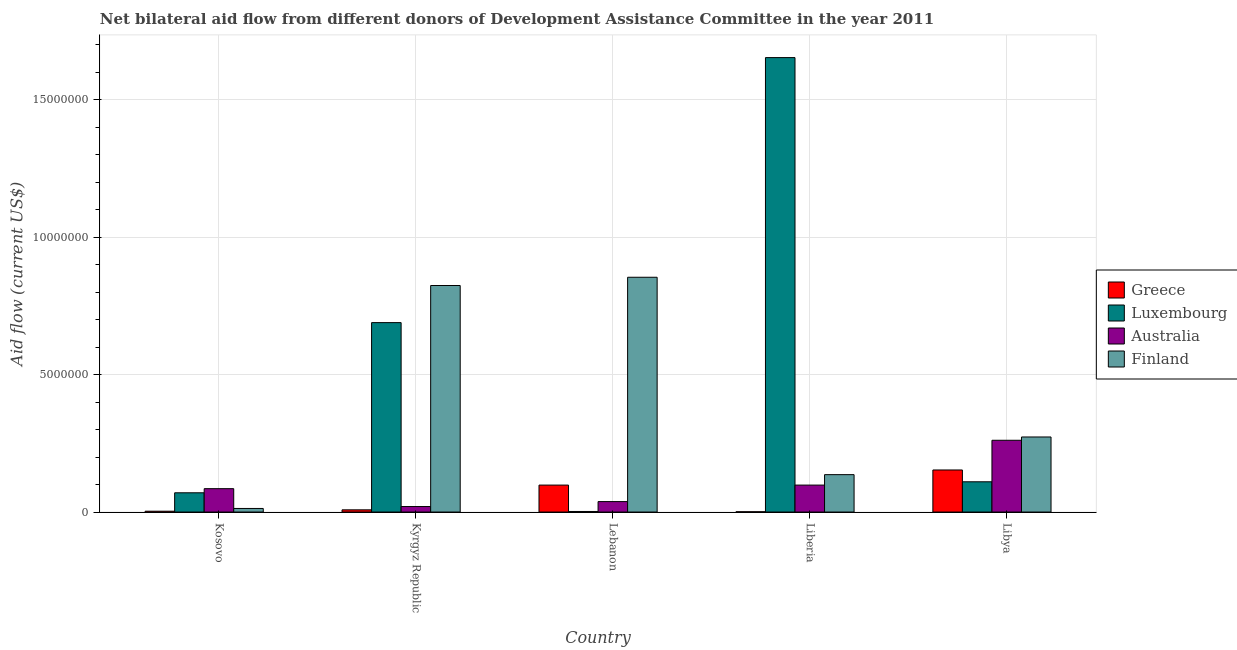How many different coloured bars are there?
Provide a short and direct response. 4. How many groups of bars are there?
Offer a very short reply. 5. Are the number of bars on each tick of the X-axis equal?
Make the answer very short. Yes. What is the label of the 2nd group of bars from the left?
Ensure brevity in your answer.  Kyrgyz Republic. In how many cases, is the number of bars for a given country not equal to the number of legend labels?
Keep it short and to the point. 0. What is the amount of aid given by finland in Libya?
Offer a very short reply. 2.73e+06. Across all countries, what is the maximum amount of aid given by finland?
Provide a succinct answer. 8.54e+06. Across all countries, what is the minimum amount of aid given by greece?
Provide a short and direct response. 10000. In which country was the amount of aid given by finland maximum?
Offer a very short reply. Lebanon. In which country was the amount of aid given by greece minimum?
Give a very brief answer. Liberia. What is the total amount of aid given by luxembourg in the graph?
Your response must be concise. 2.52e+07. What is the difference between the amount of aid given by finland in Kosovo and that in Libya?
Provide a succinct answer. -2.60e+06. What is the difference between the amount of aid given by australia in Liberia and the amount of aid given by luxembourg in Libya?
Your response must be concise. -1.20e+05. What is the average amount of aid given by luxembourg per country?
Give a very brief answer. 5.05e+06. What is the difference between the amount of aid given by australia and amount of aid given by greece in Kyrgyz Republic?
Give a very brief answer. 1.20e+05. What is the ratio of the amount of aid given by luxembourg in Lebanon to that in Libya?
Provide a short and direct response. 0.02. Is the amount of aid given by greece in Kosovo less than that in Libya?
Make the answer very short. Yes. What is the difference between the highest and the second highest amount of aid given by luxembourg?
Your answer should be very brief. 9.64e+06. What is the difference between the highest and the lowest amount of aid given by australia?
Make the answer very short. 2.41e+06. In how many countries, is the amount of aid given by greece greater than the average amount of aid given by greece taken over all countries?
Offer a very short reply. 2. Is the sum of the amount of aid given by luxembourg in Kosovo and Lebanon greater than the maximum amount of aid given by greece across all countries?
Offer a very short reply. No. Is it the case that in every country, the sum of the amount of aid given by australia and amount of aid given by greece is greater than the sum of amount of aid given by luxembourg and amount of aid given by finland?
Provide a succinct answer. No. What does the 3rd bar from the right in Kyrgyz Republic represents?
Your response must be concise. Luxembourg. How many bars are there?
Make the answer very short. 20. Are all the bars in the graph horizontal?
Your answer should be very brief. No. What is the difference between two consecutive major ticks on the Y-axis?
Provide a succinct answer. 5.00e+06. Does the graph contain any zero values?
Your response must be concise. No. How many legend labels are there?
Your answer should be very brief. 4. What is the title of the graph?
Ensure brevity in your answer.  Net bilateral aid flow from different donors of Development Assistance Committee in the year 2011. What is the label or title of the X-axis?
Offer a terse response. Country. What is the label or title of the Y-axis?
Ensure brevity in your answer.  Aid flow (current US$). What is the Aid flow (current US$) of Australia in Kosovo?
Your answer should be compact. 8.50e+05. What is the Aid flow (current US$) of Finland in Kosovo?
Provide a short and direct response. 1.30e+05. What is the Aid flow (current US$) of Luxembourg in Kyrgyz Republic?
Provide a short and direct response. 6.89e+06. What is the Aid flow (current US$) of Australia in Kyrgyz Republic?
Provide a short and direct response. 2.00e+05. What is the Aid flow (current US$) in Finland in Kyrgyz Republic?
Provide a short and direct response. 8.24e+06. What is the Aid flow (current US$) of Greece in Lebanon?
Provide a succinct answer. 9.80e+05. What is the Aid flow (current US$) of Luxembourg in Lebanon?
Provide a short and direct response. 2.00e+04. What is the Aid flow (current US$) in Finland in Lebanon?
Give a very brief answer. 8.54e+06. What is the Aid flow (current US$) of Greece in Liberia?
Make the answer very short. 10000. What is the Aid flow (current US$) in Luxembourg in Liberia?
Offer a terse response. 1.65e+07. What is the Aid flow (current US$) in Australia in Liberia?
Provide a succinct answer. 9.80e+05. What is the Aid flow (current US$) in Finland in Liberia?
Provide a short and direct response. 1.36e+06. What is the Aid flow (current US$) in Greece in Libya?
Keep it short and to the point. 1.53e+06. What is the Aid flow (current US$) in Luxembourg in Libya?
Your answer should be very brief. 1.10e+06. What is the Aid flow (current US$) in Australia in Libya?
Keep it short and to the point. 2.61e+06. What is the Aid flow (current US$) in Finland in Libya?
Ensure brevity in your answer.  2.73e+06. Across all countries, what is the maximum Aid flow (current US$) of Greece?
Your response must be concise. 1.53e+06. Across all countries, what is the maximum Aid flow (current US$) of Luxembourg?
Give a very brief answer. 1.65e+07. Across all countries, what is the maximum Aid flow (current US$) of Australia?
Your answer should be compact. 2.61e+06. Across all countries, what is the maximum Aid flow (current US$) in Finland?
Offer a terse response. 8.54e+06. Across all countries, what is the minimum Aid flow (current US$) in Australia?
Offer a very short reply. 2.00e+05. What is the total Aid flow (current US$) of Greece in the graph?
Make the answer very short. 2.63e+06. What is the total Aid flow (current US$) of Luxembourg in the graph?
Provide a short and direct response. 2.52e+07. What is the total Aid flow (current US$) of Australia in the graph?
Offer a terse response. 5.02e+06. What is the total Aid flow (current US$) of Finland in the graph?
Provide a succinct answer. 2.10e+07. What is the difference between the Aid flow (current US$) of Greece in Kosovo and that in Kyrgyz Republic?
Offer a very short reply. -5.00e+04. What is the difference between the Aid flow (current US$) of Luxembourg in Kosovo and that in Kyrgyz Republic?
Ensure brevity in your answer.  -6.19e+06. What is the difference between the Aid flow (current US$) in Australia in Kosovo and that in Kyrgyz Republic?
Provide a short and direct response. 6.50e+05. What is the difference between the Aid flow (current US$) of Finland in Kosovo and that in Kyrgyz Republic?
Offer a terse response. -8.11e+06. What is the difference between the Aid flow (current US$) in Greece in Kosovo and that in Lebanon?
Your answer should be very brief. -9.50e+05. What is the difference between the Aid flow (current US$) in Luxembourg in Kosovo and that in Lebanon?
Ensure brevity in your answer.  6.80e+05. What is the difference between the Aid flow (current US$) in Finland in Kosovo and that in Lebanon?
Your response must be concise. -8.41e+06. What is the difference between the Aid flow (current US$) of Luxembourg in Kosovo and that in Liberia?
Give a very brief answer. -1.58e+07. What is the difference between the Aid flow (current US$) in Australia in Kosovo and that in Liberia?
Offer a terse response. -1.30e+05. What is the difference between the Aid flow (current US$) in Finland in Kosovo and that in Liberia?
Your response must be concise. -1.23e+06. What is the difference between the Aid flow (current US$) in Greece in Kosovo and that in Libya?
Make the answer very short. -1.50e+06. What is the difference between the Aid flow (current US$) in Luxembourg in Kosovo and that in Libya?
Offer a terse response. -4.00e+05. What is the difference between the Aid flow (current US$) in Australia in Kosovo and that in Libya?
Provide a short and direct response. -1.76e+06. What is the difference between the Aid flow (current US$) of Finland in Kosovo and that in Libya?
Provide a short and direct response. -2.60e+06. What is the difference between the Aid flow (current US$) in Greece in Kyrgyz Republic and that in Lebanon?
Your answer should be compact. -9.00e+05. What is the difference between the Aid flow (current US$) in Luxembourg in Kyrgyz Republic and that in Lebanon?
Provide a succinct answer. 6.87e+06. What is the difference between the Aid flow (current US$) in Australia in Kyrgyz Republic and that in Lebanon?
Make the answer very short. -1.80e+05. What is the difference between the Aid flow (current US$) in Greece in Kyrgyz Republic and that in Liberia?
Offer a very short reply. 7.00e+04. What is the difference between the Aid flow (current US$) in Luxembourg in Kyrgyz Republic and that in Liberia?
Offer a very short reply. -9.64e+06. What is the difference between the Aid flow (current US$) of Australia in Kyrgyz Republic and that in Liberia?
Make the answer very short. -7.80e+05. What is the difference between the Aid flow (current US$) of Finland in Kyrgyz Republic and that in Liberia?
Ensure brevity in your answer.  6.88e+06. What is the difference between the Aid flow (current US$) in Greece in Kyrgyz Republic and that in Libya?
Offer a terse response. -1.45e+06. What is the difference between the Aid flow (current US$) of Luxembourg in Kyrgyz Republic and that in Libya?
Offer a terse response. 5.79e+06. What is the difference between the Aid flow (current US$) of Australia in Kyrgyz Republic and that in Libya?
Ensure brevity in your answer.  -2.41e+06. What is the difference between the Aid flow (current US$) of Finland in Kyrgyz Republic and that in Libya?
Give a very brief answer. 5.51e+06. What is the difference between the Aid flow (current US$) in Greece in Lebanon and that in Liberia?
Your answer should be very brief. 9.70e+05. What is the difference between the Aid flow (current US$) of Luxembourg in Lebanon and that in Liberia?
Provide a short and direct response. -1.65e+07. What is the difference between the Aid flow (current US$) of Australia in Lebanon and that in Liberia?
Offer a terse response. -6.00e+05. What is the difference between the Aid flow (current US$) of Finland in Lebanon and that in Liberia?
Offer a very short reply. 7.18e+06. What is the difference between the Aid flow (current US$) of Greece in Lebanon and that in Libya?
Provide a short and direct response. -5.50e+05. What is the difference between the Aid flow (current US$) in Luxembourg in Lebanon and that in Libya?
Give a very brief answer. -1.08e+06. What is the difference between the Aid flow (current US$) of Australia in Lebanon and that in Libya?
Make the answer very short. -2.23e+06. What is the difference between the Aid flow (current US$) of Finland in Lebanon and that in Libya?
Give a very brief answer. 5.81e+06. What is the difference between the Aid flow (current US$) of Greece in Liberia and that in Libya?
Provide a short and direct response. -1.52e+06. What is the difference between the Aid flow (current US$) of Luxembourg in Liberia and that in Libya?
Offer a terse response. 1.54e+07. What is the difference between the Aid flow (current US$) in Australia in Liberia and that in Libya?
Offer a terse response. -1.63e+06. What is the difference between the Aid flow (current US$) of Finland in Liberia and that in Libya?
Give a very brief answer. -1.37e+06. What is the difference between the Aid flow (current US$) in Greece in Kosovo and the Aid flow (current US$) in Luxembourg in Kyrgyz Republic?
Ensure brevity in your answer.  -6.86e+06. What is the difference between the Aid flow (current US$) in Greece in Kosovo and the Aid flow (current US$) in Australia in Kyrgyz Republic?
Offer a very short reply. -1.70e+05. What is the difference between the Aid flow (current US$) in Greece in Kosovo and the Aid flow (current US$) in Finland in Kyrgyz Republic?
Keep it short and to the point. -8.21e+06. What is the difference between the Aid flow (current US$) of Luxembourg in Kosovo and the Aid flow (current US$) of Finland in Kyrgyz Republic?
Offer a terse response. -7.54e+06. What is the difference between the Aid flow (current US$) of Australia in Kosovo and the Aid flow (current US$) of Finland in Kyrgyz Republic?
Offer a terse response. -7.39e+06. What is the difference between the Aid flow (current US$) of Greece in Kosovo and the Aid flow (current US$) of Australia in Lebanon?
Offer a terse response. -3.50e+05. What is the difference between the Aid flow (current US$) of Greece in Kosovo and the Aid flow (current US$) of Finland in Lebanon?
Provide a short and direct response. -8.51e+06. What is the difference between the Aid flow (current US$) in Luxembourg in Kosovo and the Aid flow (current US$) in Australia in Lebanon?
Your response must be concise. 3.20e+05. What is the difference between the Aid flow (current US$) of Luxembourg in Kosovo and the Aid flow (current US$) of Finland in Lebanon?
Give a very brief answer. -7.84e+06. What is the difference between the Aid flow (current US$) in Australia in Kosovo and the Aid flow (current US$) in Finland in Lebanon?
Give a very brief answer. -7.69e+06. What is the difference between the Aid flow (current US$) of Greece in Kosovo and the Aid flow (current US$) of Luxembourg in Liberia?
Offer a very short reply. -1.65e+07. What is the difference between the Aid flow (current US$) in Greece in Kosovo and the Aid flow (current US$) in Australia in Liberia?
Your answer should be very brief. -9.50e+05. What is the difference between the Aid flow (current US$) in Greece in Kosovo and the Aid flow (current US$) in Finland in Liberia?
Provide a succinct answer. -1.33e+06. What is the difference between the Aid flow (current US$) of Luxembourg in Kosovo and the Aid flow (current US$) of Australia in Liberia?
Provide a short and direct response. -2.80e+05. What is the difference between the Aid flow (current US$) of Luxembourg in Kosovo and the Aid flow (current US$) of Finland in Liberia?
Keep it short and to the point. -6.60e+05. What is the difference between the Aid flow (current US$) in Australia in Kosovo and the Aid flow (current US$) in Finland in Liberia?
Provide a short and direct response. -5.10e+05. What is the difference between the Aid flow (current US$) in Greece in Kosovo and the Aid flow (current US$) in Luxembourg in Libya?
Your answer should be very brief. -1.07e+06. What is the difference between the Aid flow (current US$) in Greece in Kosovo and the Aid flow (current US$) in Australia in Libya?
Give a very brief answer. -2.58e+06. What is the difference between the Aid flow (current US$) in Greece in Kosovo and the Aid flow (current US$) in Finland in Libya?
Offer a very short reply. -2.70e+06. What is the difference between the Aid flow (current US$) of Luxembourg in Kosovo and the Aid flow (current US$) of Australia in Libya?
Ensure brevity in your answer.  -1.91e+06. What is the difference between the Aid flow (current US$) of Luxembourg in Kosovo and the Aid flow (current US$) of Finland in Libya?
Give a very brief answer. -2.03e+06. What is the difference between the Aid flow (current US$) in Australia in Kosovo and the Aid flow (current US$) in Finland in Libya?
Ensure brevity in your answer.  -1.88e+06. What is the difference between the Aid flow (current US$) in Greece in Kyrgyz Republic and the Aid flow (current US$) in Finland in Lebanon?
Provide a succinct answer. -8.46e+06. What is the difference between the Aid flow (current US$) of Luxembourg in Kyrgyz Republic and the Aid flow (current US$) of Australia in Lebanon?
Provide a succinct answer. 6.51e+06. What is the difference between the Aid flow (current US$) in Luxembourg in Kyrgyz Republic and the Aid flow (current US$) in Finland in Lebanon?
Your answer should be compact. -1.65e+06. What is the difference between the Aid flow (current US$) of Australia in Kyrgyz Republic and the Aid flow (current US$) of Finland in Lebanon?
Your answer should be compact. -8.34e+06. What is the difference between the Aid flow (current US$) in Greece in Kyrgyz Republic and the Aid flow (current US$) in Luxembourg in Liberia?
Your response must be concise. -1.64e+07. What is the difference between the Aid flow (current US$) of Greece in Kyrgyz Republic and the Aid flow (current US$) of Australia in Liberia?
Make the answer very short. -9.00e+05. What is the difference between the Aid flow (current US$) in Greece in Kyrgyz Republic and the Aid flow (current US$) in Finland in Liberia?
Provide a short and direct response. -1.28e+06. What is the difference between the Aid flow (current US$) of Luxembourg in Kyrgyz Republic and the Aid flow (current US$) of Australia in Liberia?
Your answer should be very brief. 5.91e+06. What is the difference between the Aid flow (current US$) in Luxembourg in Kyrgyz Republic and the Aid flow (current US$) in Finland in Liberia?
Make the answer very short. 5.53e+06. What is the difference between the Aid flow (current US$) of Australia in Kyrgyz Republic and the Aid flow (current US$) of Finland in Liberia?
Make the answer very short. -1.16e+06. What is the difference between the Aid flow (current US$) of Greece in Kyrgyz Republic and the Aid flow (current US$) of Luxembourg in Libya?
Offer a terse response. -1.02e+06. What is the difference between the Aid flow (current US$) in Greece in Kyrgyz Republic and the Aid flow (current US$) in Australia in Libya?
Offer a very short reply. -2.53e+06. What is the difference between the Aid flow (current US$) of Greece in Kyrgyz Republic and the Aid flow (current US$) of Finland in Libya?
Your answer should be compact. -2.65e+06. What is the difference between the Aid flow (current US$) of Luxembourg in Kyrgyz Republic and the Aid flow (current US$) of Australia in Libya?
Make the answer very short. 4.28e+06. What is the difference between the Aid flow (current US$) in Luxembourg in Kyrgyz Republic and the Aid flow (current US$) in Finland in Libya?
Give a very brief answer. 4.16e+06. What is the difference between the Aid flow (current US$) of Australia in Kyrgyz Republic and the Aid flow (current US$) of Finland in Libya?
Ensure brevity in your answer.  -2.53e+06. What is the difference between the Aid flow (current US$) in Greece in Lebanon and the Aid flow (current US$) in Luxembourg in Liberia?
Provide a succinct answer. -1.56e+07. What is the difference between the Aid flow (current US$) in Greece in Lebanon and the Aid flow (current US$) in Finland in Liberia?
Your answer should be compact. -3.80e+05. What is the difference between the Aid flow (current US$) in Luxembourg in Lebanon and the Aid flow (current US$) in Australia in Liberia?
Give a very brief answer. -9.60e+05. What is the difference between the Aid flow (current US$) in Luxembourg in Lebanon and the Aid flow (current US$) in Finland in Liberia?
Your response must be concise. -1.34e+06. What is the difference between the Aid flow (current US$) of Australia in Lebanon and the Aid flow (current US$) of Finland in Liberia?
Provide a succinct answer. -9.80e+05. What is the difference between the Aid flow (current US$) in Greece in Lebanon and the Aid flow (current US$) in Luxembourg in Libya?
Give a very brief answer. -1.20e+05. What is the difference between the Aid flow (current US$) of Greece in Lebanon and the Aid flow (current US$) of Australia in Libya?
Ensure brevity in your answer.  -1.63e+06. What is the difference between the Aid flow (current US$) in Greece in Lebanon and the Aid flow (current US$) in Finland in Libya?
Offer a very short reply. -1.75e+06. What is the difference between the Aid flow (current US$) in Luxembourg in Lebanon and the Aid flow (current US$) in Australia in Libya?
Your response must be concise. -2.59e+06. What is the difference between the Aid flow (current US$) in Luxembourg in Lebanon and the Aid flow (current US$) in Finland in Libya?
Provide a short and direct response. -2.71e+06. What is the difference between the Aid flow (current US$) of Australia in Lebanon and the Aid flow (current US$) of Finland in Libya?
Your answer should be very brief. -2.35e+06. What is the difference between the Aid flow (current US$) of Greece in Liberia and the Aid flow (current US$) of Luxembourg in Libya?
Your response must be concise. -1.09e+06. What is the difference between the Aid flow (current US$) of Greece in Liberia and the Aid flow (current US$) of Australia in Libya?
Provide a short and direct response. -2.60e+06. What is the difference between the Aid flow (current US$) of Greece in Liberia and the Aid flow (current US$) of Finland in Libya?
Your answer should be compact. -2.72e+06. What is the difference between the Aid flow (current US$) of Luxembourg in Liberia and the Aid flow (current US$) of Australia in Libya?
Your answer should be compact. 1.39e+07. What is the difference between the Aid flow (current US$) of Luxembourg in Liberia and the Aid flow (current US$) of Finland in Libya?
Give a very brief answer. 1.38e+07. What is the difference between the Aid flow (current US$) in Australia in Liberia and the Aid flow (current US$) in Finland in Libya?
Offer a terse response. -1.75e+06. What is the average Aid flow (current US$) of Greece per country?
Keep it short and to the point. 5.26e+05. What is the average Aid flow (current US$) of Luxembourg per country?
Your response must be concise. 5.05e+06. What is the average Aid flow (current US$) of Australia per country?
Your answer should be compact. 1.00e+06. What is the average Aid flow (current US$) of Finland per country?
Offer a terse response. 4.20e+06. What is the difference between the Aid flow (current US$) of Greece and Aid flow (current US$) of Luxembourg in Kosovo?
Your answer should be compact. -6.70e+05. What is the difference between the Aid flow (current US$) in Greece and Aid flow (current US$) in Australia in Kosovo?
Offer a terse response. -8.20e+05. What is the difference between the Aid flow (current US$) of Greece and Aid flow (current US$) of Finland in Kosovo?
Offer a terse response. -1.00e+05. What is the difference between the Aid flow (current US$) of Luxembourg and Aid flow (current US$) of Finland in Kosovo?
Make the answer very short. 5.70e+05. What is the difference between the Aid flow (current US$) of Australia and Aid flow (current US$) of Finland in Kosovo?
Your response must be concise. 7.20e+05. What is the difference between the Aid flow (current US$) in Greece and Aid flow (current US$) in Luxembourg in Kyrgyz Republic?
Your answer should be very brief. -6.81e+06. What is the difference between the Aid flow (current US$) in Greece and Aid flow (current US$) in Finland in Kyrgyz Republic?
Provide a succinct answer. -8.16e+06. What is the difference between the Aid flow (current US$) of Luxembourg and Aid flow (current US$) of Australia in Kyrgyz Republic?
Make the answer very short. 6.69e+06. What is the difference between the Aid flow (current US$) of Luxembourg and Aid flow (current US$) of Finland in Kyrgyz Republic?
Make the answer very short. -1.35e+06. What is the difference between the Aid flow (current US$) of Australia and Aid flow (current US$) of Finland in Kyrgyz Republic?
Ensure brevity in your answer.  -8.04e+06. What is the difference between the Aid flow (current US$) in Greece and Aid flow (current US$) in Luxembourg in Lebanon?
Provide a succinct answer. 9.60e+05. What is the difference between the Aid flow (current US$) in Greece and Aid flow (current US$) in Australia in Lebanon?
Make the answer very short. 6.00e+05. What is the difference between the Aid flow (current US$) of Greece and Aid flow (current US$) of Finland in Lebanon?
Give a very brief answer. -7.56e+06. What is the difference between the Aid flow (current US$) of Luxembourg and Aid flow (current US$) of Australia in Lebanon?
Your answer should be very brief. -3.60e+05. What is the difference between the Aid flow (current US$) of Luxembourg and Aid flow (current US$) of Finland in Lebanon?
Provide a succinct answer. -8.52e+06. What is the difference between the Aid flow (current US$) of Australia and Aid flow (current US$) of Finland in Lebanon?
Make the answer very short. -8.16e+06. What is the difference between the Aid flow (current US$) of Greece and Aid flow (current US$) of Luxembourg in Liberia?
Provide a short and direct response. -1.65e+07. What is the difference between the Aid flow (current US$) of Greece and Aid flow (current US$) of Australia in Liberia?
Provide a succinct answer. -9.70e+05. What is the difference between the Aid flow (current US$) in Greece and Aid flow (current US$) in Finland in Liberia?
Your response must be concise. -1.35e+06. What is the difference between the Aid flow (current US$) in Luxembourg and Aid flow (current US$) in Australia in Liberia?
Your answer should be compact. 1.56e+07. What is the difference between the Aid flow (current US$) in Luxembourg and Aid flow (current US$) in Finland in Liberia?
Offer a terse response. 1.52e+07. What is the difference between the Aid flow (current US$) in Australia and Aid flow (current US$) in Finland in Liberia?
Ensure brevity in your answer.  -3.80e+05. What is the difference between the Aid flow (current US$) in Greece and Aid flow (current US$) in Australia in Libya?
Offer a very short reply. -1.08e+06. What is the difference between the Aid flow (current US$) in Greece and Aid flow (current US$) in Finland in Libya?
Your answer should be compact. -1.20e+06. What is the difference between the Aid flow (current US$) in Luxembourg and Aid flow (current US$) in Australia in Libya?
Offer a very short reply. -1.51e+06. What is the difference between the Aid flow (current US$) of Luxembourg and Aid flow (current US$) of Finland in Libya?
Make the answer very short. -1.63e+06. What is the difference between the Aid flow (current US$) in Australia and Aid flow (current US$) in Finland in Libya?
Offer a very short reply. -1.20e+05. What is the ratio of the Aid flow (current US$) in Luxembourg in Kosovo to that in Kyrgyz Republic?
Your answer should be very brief. 0.1. What is the ratio of the Aid flow (current US$) in Australia in Kosovo to that in Kyrgyz Republic?
Make the answer very short. 4.25. What is the ratio of the Aid flow (current US$) in Finland in Kosovo to that in Kyrgyz Republic?
Your answer should be very brief. 0.02. What is the ratio of the Aid flow (current US$) of Greece in Kosovo to that in Lebanon?
Your answer should be compact. 0.03. What is the ratio of the Aid flow (current US$) in Australia in Kosovo to that in Lebanon?
Make the answer very short. 2.24. What is the ratio of the Aid flow (current US$) in Finland in Kosovo to that in Lebanon?
Provide a short and direct response. 0.02. What is the ratio of the Aid flow (current US$) in Luxembourg in Kosovo to that in Liberia?
Make the answer very short. 0.04. What is the ratio of the Aid flow (current US$) of Australia in Kosovo to that in Liberia?
Offer a terse response. 0.87. What is the ratio of the Aid flow (current US$) in Finland in Kosovo to that in Liberia?
Offer a terse response. 0.1. What is the ratio of the Aid flow (current US$) in Greece in Kosovo to that in Libya?
Provide a succinct answer. 0.02. What is the ratio of the Aid flow (current US$) in Luxembourg in Kosovo to that in Libya?
Offer a very short reply. 0.64. What is the ratio of the Aid flow (current US$) in Australia in Kosovo to that in Libya?
Offer a very short reply. 0.33. What is the ratio of the Aid flow (current US$) in Finland in Kosovo to that in Libya?
Your response must be concise. 0.05. What is the ratio of the Aid flow (current US$) in Greece in Kyrgyz Republic to that in Lebanon?
Provide a succinct answer. 0.08. What is the ratio of the Aid flow (current US$) in Luxembourg in Kyrgyz Republic to that in Lebanon?
Your answer should be very brief. 344.5. What is the ratio of the Aid flow (current US$) of Australia in Kyrgyz Republic to that in Lebanon?
Offer a terse response. 0.53. What is the ratio of the Aid flow (current US$) of Finland in Kyrgyz Republic to that in Lebanon?
Your answer should be very brief. 0.96. What is the ratio of the Aid flow (current US$) in Greece in Kyrgyz Republic to that in Liberia?
Give a very brief answer. 8. What is the ratio of the Aid flow (current US$) of Luxembourg in Kyrgyz Republic to that in Liberia?
Offer a very short reply. 0.42. What is the ratio of the Aid flow (current US$) of Australia in Kyrgyz Republic to that in Liberia?
Provide a succinct answer. 0.2. What is the ratio of the Aid flow (current US$) of Finland in Kyrgyz Republic to that in Liberia?
Make the answer very short. 6.06. What is the ratio of the Aid flow (current US$) of Greece in Kyrgyz Republic to that in Libya?
Give a very brief answer. 0.05. What is the ratio of the Aid flow (current US$) of Luxembourg in Kyrgyz Republic to that in Libya?
Your response must be concise. 6.26. What is the ratio of the Aid flow (current US$) of Australia in Kyrgyz Republic to that in Libya?
Make the answer very short. 0.08. What is the ratio of the Aid flow (current US$) in Finland in Kyrgyz Republic to that in Libya?
Your response must be concise. 3.02. What is the ratio of the Aid flow (current US$) in Greece in Lebanon to that in Liberia?
Ensure brevity in your answer.  98. What is the ratio of the Aid flow (current US$) of Luxembourg in Lebanon to that in Liberia?
Offer a terse response. 0. What is the ratio of the Aid flow (current US$) in Australia in Lebanon to that in Liberia?
Keep it short and to the point. 0.39. What is the ratio of the Aid flow (current US$) in Finland in Lebanon to that in Liberia?
Offer a terse response. 6.28. What is the ratio of the Aid flow (current US$) in Greece in Lebanon to that in Libya?
Give a very brief answer. 0.64. What is the ratio of the Aid flow (current US$) of Luxembourg in Lebanon to that in Libya?
Offer a terse response. 0.02. What is the ratio of the Aid flow (current US$) in Australia in Lebanon to that in Libya?
Your response must be concise. 0.15. What is the ratio of the Aid flow (current US$) of Finland in Lebanon to that in Libya?
Provide a short and direct response. 3.13. What is the ratio of the Aid flow (current US$) in Greece in Liberia to that in Libya?
Your response must be concise. 0.01. What is the ratio of the Aid flow (current US$) in Luxembourg in Liberia to that in Libya?
Your response must be concise. 15.03. What is the ratio of the Aid flow (current US$) of Australia in Liberia to that in Libya?
Provide a succinct answer. 0.38. What is the ratio of the Aid flow (current US$) of Finland in Liberia to that in Libya?
Your answer should be compact. 0.5. What is the difference between the highest and the second highest Aid flow (current US$) of Luxembourg?
Your answer should be very brief. 9.64e+06. What is the difference between the highest and the second highest Aid flow (current US$) of Australia?
Provide a short and direct response. 1.63e+06. What is the difference between the highest and the second highest Aid flow (current US$) of Finland?
Provide a succinct answer. 3.00e+05. What is the difference between the highest and the lowest Aid flow (current US$) of Greece?
Offer a terse response. 1.52e+06. What is the difference between the highest and the lowest Aid flow (current US$) in Luxembourg?
Give a very brief answer. 1.65e+07. What is the difference between the highest and the lowest Aid flow (current US$) in Australia?
Make the answer very short. 2.41e+06. What is the difference between the highest and the lowest Aid flow (current US$) in Finland?
Ensure brevity in your answer.  8.41e+06. 